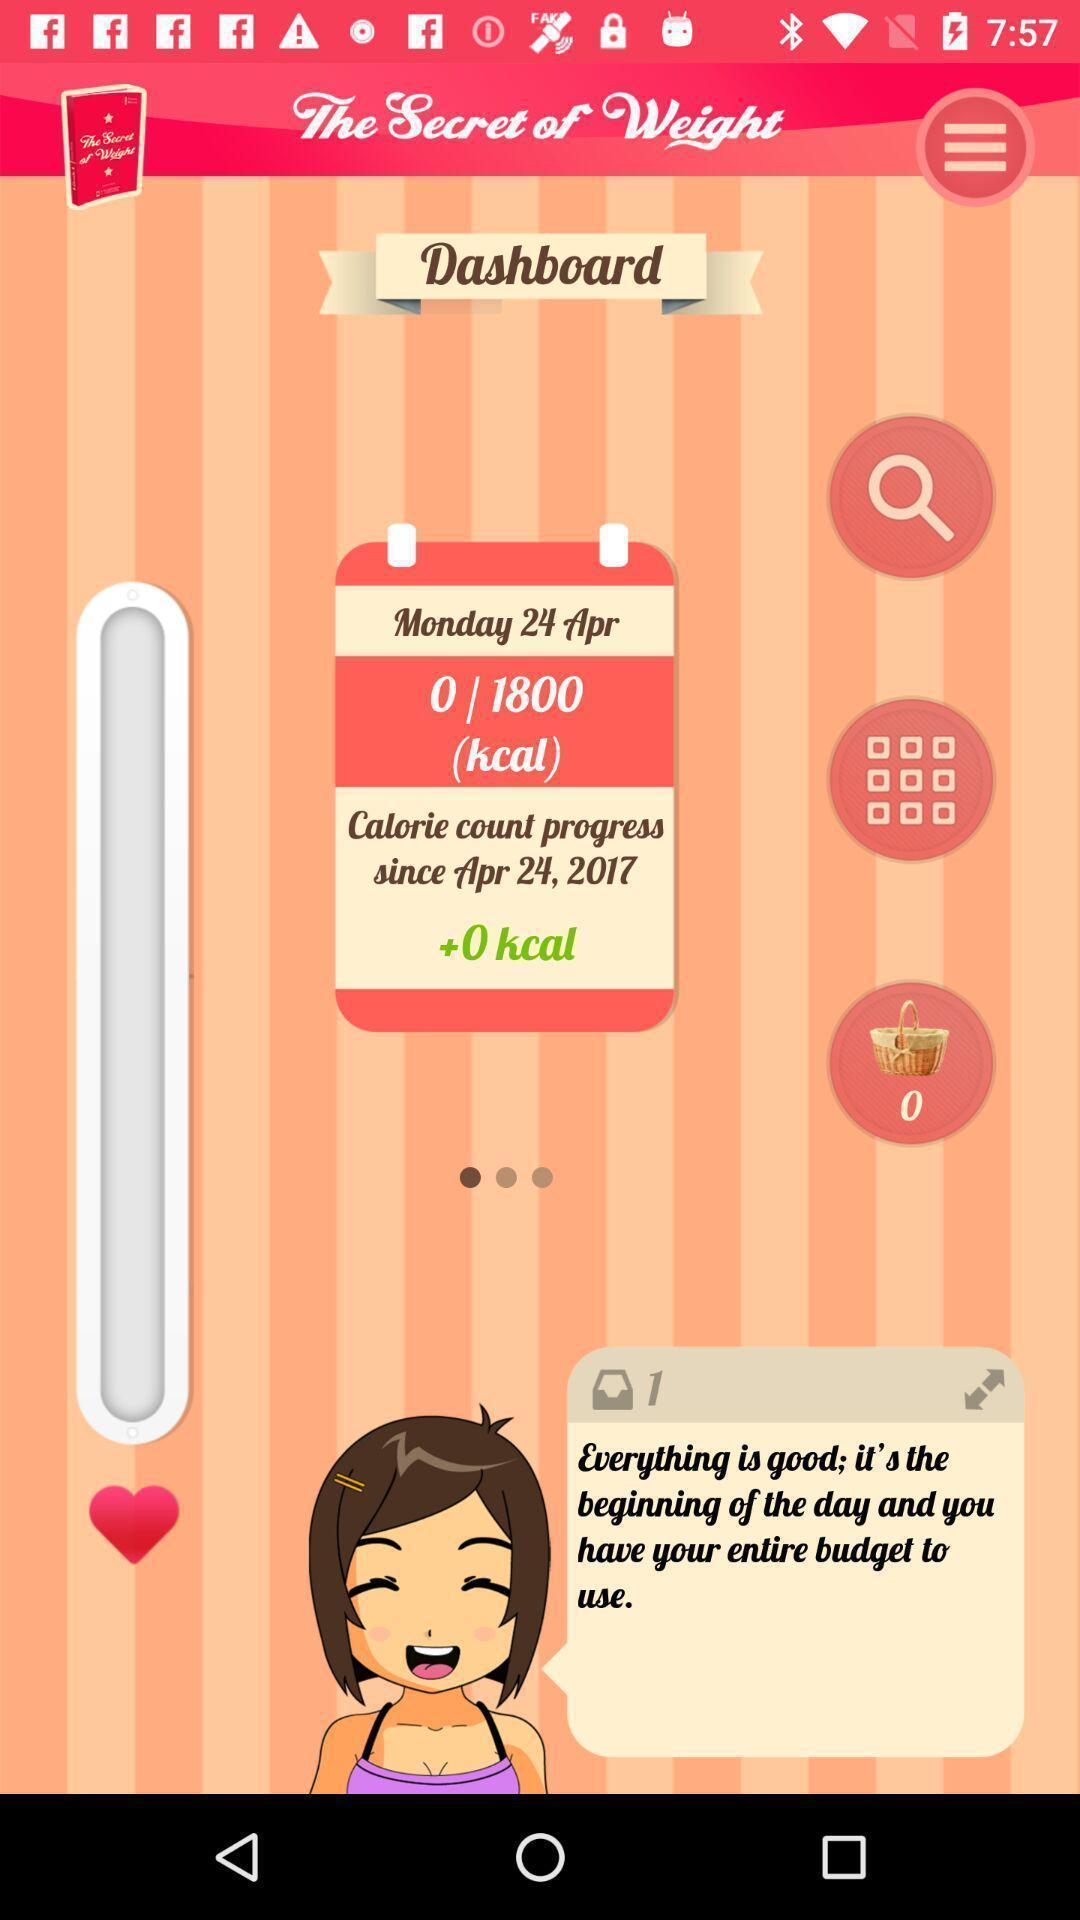Give me a narrative description of this picture. Screen shows multiple options in a fitness application. 